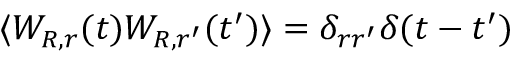<formula> <loc_0><loc_0><loc_500><loc_500>\langle W _ { R , r } ( t ) W _ { R , r ^ { \prime } } ( t ^ { \prime } ) \rangle = \delta _ { r r ^ { \prime } } \delta ( t - t ^ { \prime } )</formula> 